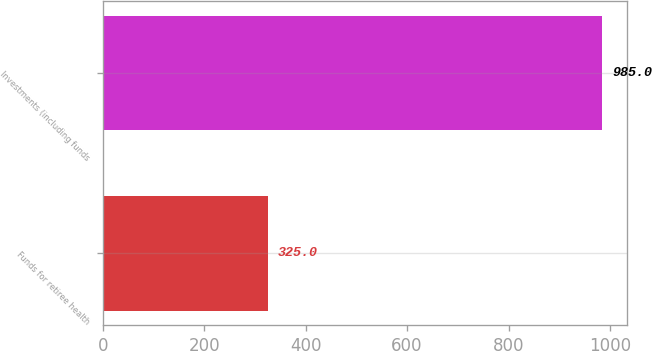<chart> <loc_0><loc_0><loc_500><loc_500><bar_chart><fcel>Funds for retiree health<fcel>Investments (including funds<nl><fcel>325<fcel>985<nl></chart> 